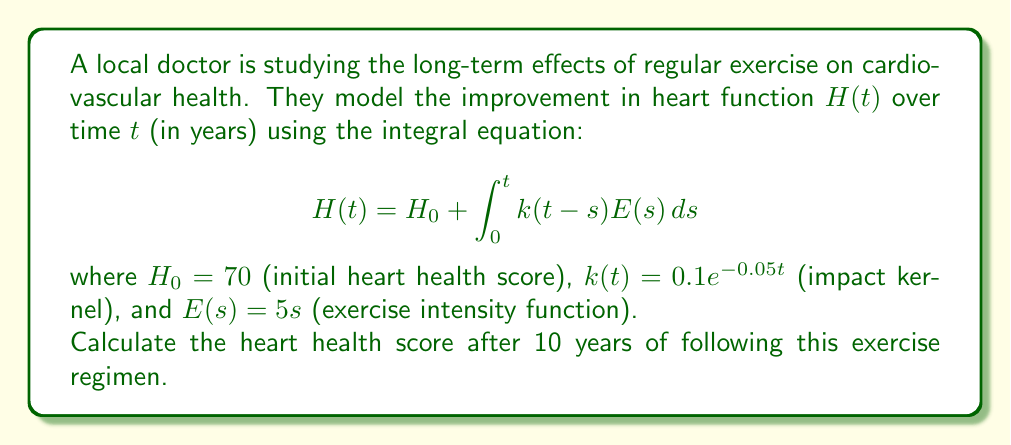Can you solve this math problem? To solve this integral equation, we follow these steps:

1) Substitute the given functions into the integral equation:
   $$H(10) = 70 + \int_0^{10} 0.1e^{-0.05(10-s)}(5s)ds$$

2) Simplify the integrand:
   $$H(10) = 70 + 0.5\int_0^{10} se^{-0.05(10-s)}ds$$

3) Use integration by parts with $u = s$ and $dv = e^{-0.05(10-s)}ds$:
   $$H(10) = 70 + 0.5[-20se^{-0.05(10-s)}]_0^{10} + 0.5\int_0^{10} 20e^{-0.05(10-s)}ds$$

4) Evaluate the first term and simplify the second integral:
   $$H(10) = 70 - 10e^0 + 0 + 10\int_0^{10} e^{-0.05(10-s)}ds$$

5) Solve the remaining integral:
   $$H(10) = 60 + 10[-20e^{-0.05(10-s)}]_0^{10}$$

6) Evaluate the limits:
   $$H(10) = 60 + 10[-20e^0 + 20e^{-0.5}]$$

7) Calculate the final result:
   $$H(10) = 60 - 200 + 200e^{-0.5} \approx 81.32$$
Answer: $81.32$ 